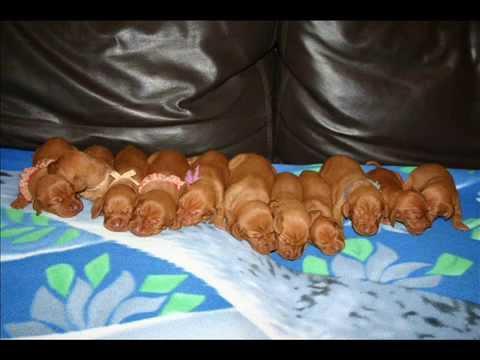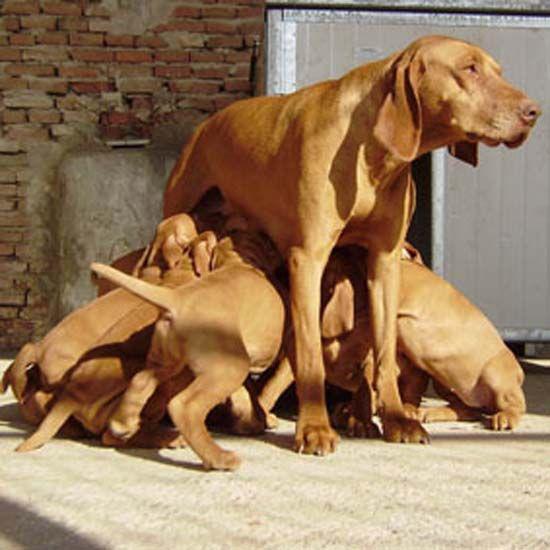The first image is the image on the left, the second image is the image on the right. For the images displayed, is the sentence "There are more than three puppies sleeping in the image." factually correct? Answer yes or no. Yes. The first image is the image on the left, the second image is the image on the right. Given the left and right images, does the statement "One image shows a container holding seven red-orange puppies, and the other image shows one sleeping adult dog." hold true? Answer yes or no. No. 